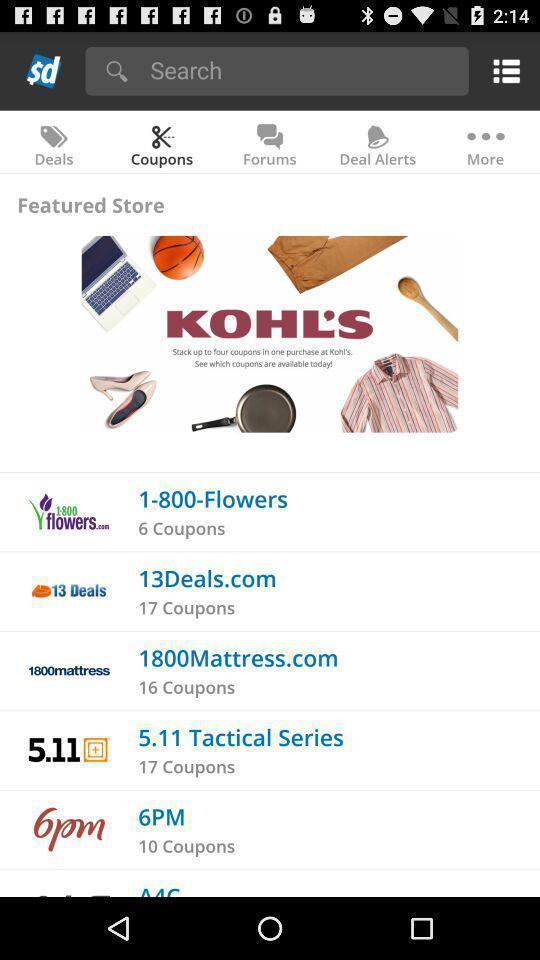What is the overall content of this screenshot? Store coupons displaying in this page. 